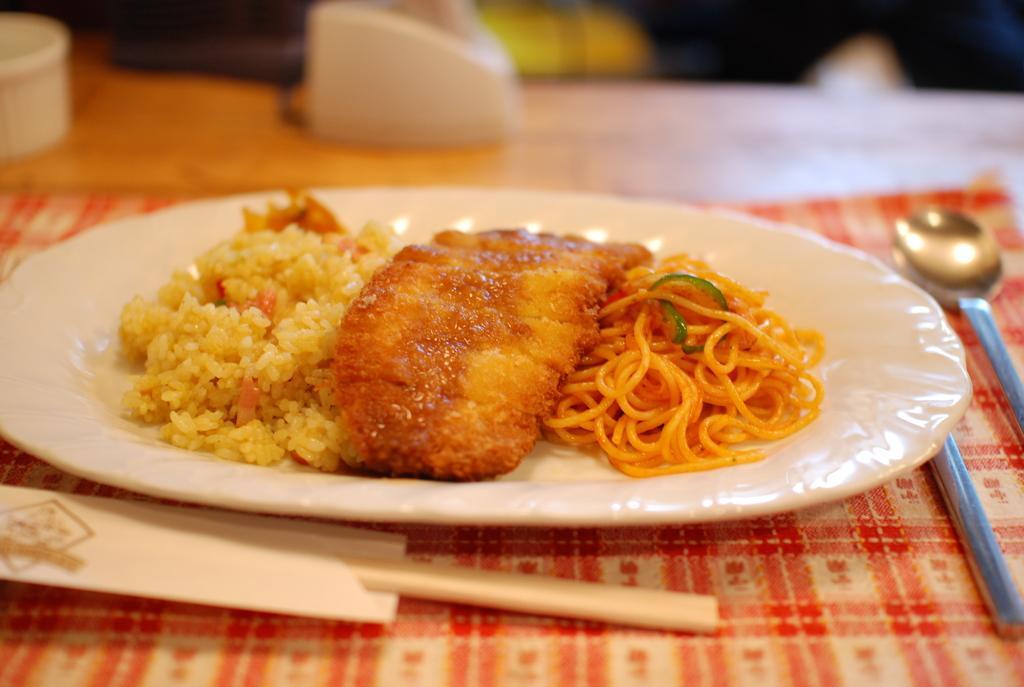In one or two sentences, can you explain what this image depicts? In this picture there is a food and some noodles in the white plate. Behind we can see a spoon which is placed on the table top. 